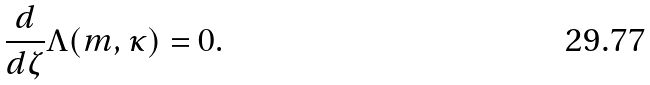<formula> <loc_0><loc_0><loc_500><loc_500>\frac { d } { d \zeta } \Lambda ( m , \kappa ) = 0 .</formula> 